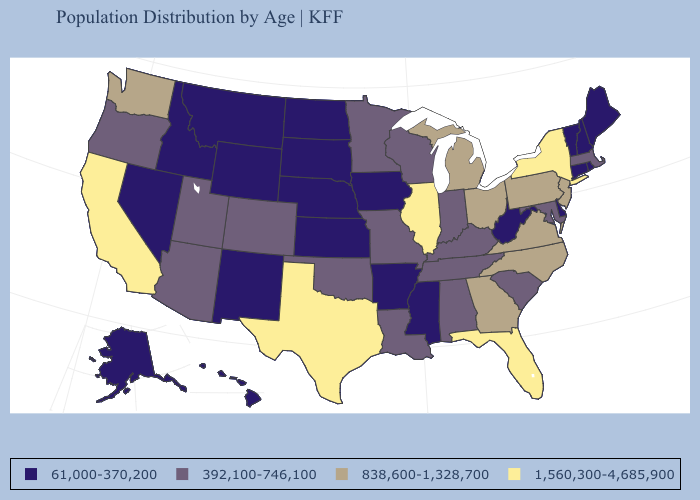What is the highest value in the MidWest ?
Short answer required. 1,560,300-4,685,900. Does the map have missing data?
Write a very short answer. No. Which states have the lowest value in the USA?
Keep it brief. Alaska, Arkansas, Connecticut, Delaware, Hawaii, Idaho, Iowa, Kansas, Maine, Mississippi, Montana, Nebraska, Nevada, New Hampshire, New Mexico, North Dakota, Rhode Island, South Dakota, Vermont, West Virginia, Wyoming. What is the value of Missouri?
Short answer required. 392,100-746,100. Which states have the lowest value in the USA?
Write a very short answer. Alaska, Arkansas, Connecticut, Delaware, Hawaii, Idaho, Iowa, Kansas, Maine, Mississippi, Montana, Nebraska, Nevada, New Hampshire, New Mexico, North Dakota, Rhode Island, South Dakota, Vermont, West Virginia, Wyoming. What is the highest value in the USA?
Be succinct. 1,560,300-4,685,900. Name the states that have a value in the range 838,600-1,328,700?
Give a very brief answer. Georgia, Michigan, New Jersey, North Carolina, Ohio, Pennsylvania, Virginia, Washington. What is the lowest value in the West?
Quick response, please. 61,000-370,200. Does Texas have a lower value than Illinois?
Quick response, please. No. What is the value of Pennsylvania?
Concise answer only. 838,600-1,328,700. Is the legend a continuous bar?
Quick response, please. No. What is the lowest value in the USA?
Write a very short answer. 61,000-370,200. Name the states that have a value in the range 392,100-746,100?
Answer briefly. Alabama, Arizona, Colorado, Indiana, Kentucky, Louisiana, Maryland, Massachusetts, Minnesota, Missouri, Oklahoma, Oregon, South Carolina, Tennessee, Utah, Wisconsin. What is the highest value in states that border Florida?
Concise answer only. 838,600-1,328,700. Is the legend a continuous bar?
Be succinct. No. 